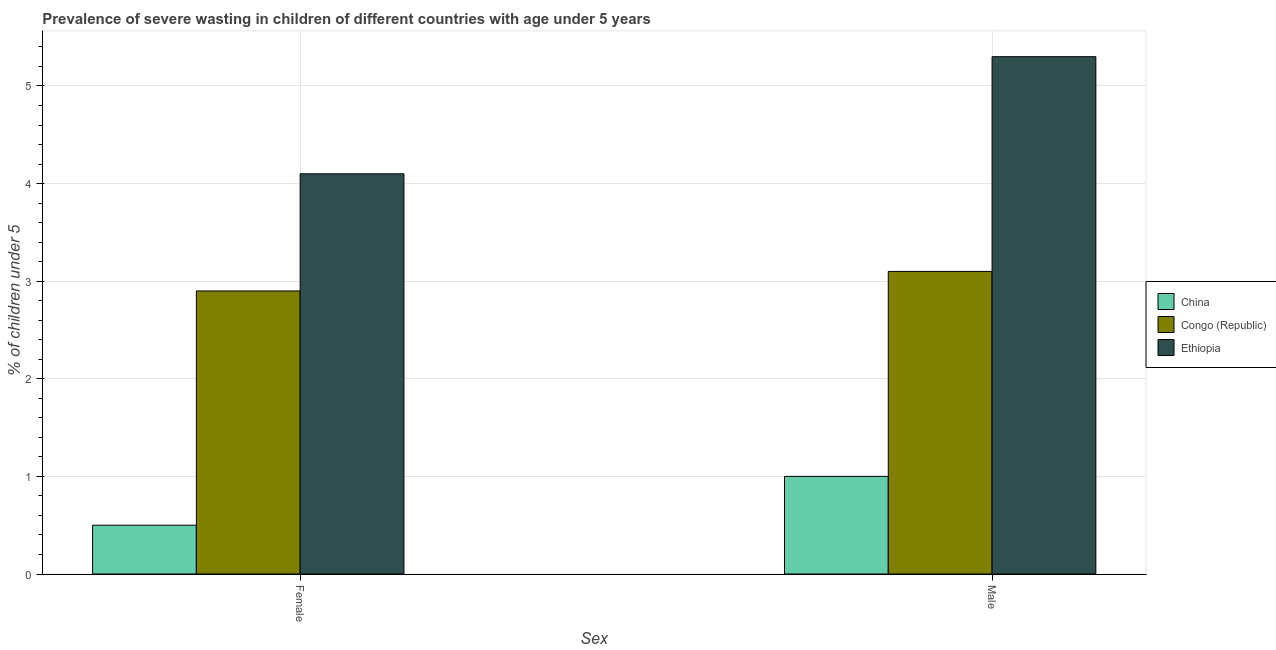How many different coloured bars are there?
Ensure brevity in your answer.  3. How many bars are there on the 2nd tick from the left?
Provide a succinct answer. 3. How many bars are there on the 1st tick from the right?
Keep it short and to the point. 3. What is the percentage of undernourished male children in Congo (Republic)?
Your response must be concise. 3.1. Across all countries, what is the maximum percentage of undernourished male children?
Make the answer very short. 5.3. Across all countries, what is the minimum percentage of undernourished female children?
Give a very brief answer. 0.5. In which country was the percentage of undernourished male children maximum?
Your answer should be compact. Ethiopia. What is the total percentage of undernourished male children in the graph?
Your answer should be very brief. 9.4. What is the difference between the percentage of undernourished male children in China and that in Congo (Republic)?
Keep it short and to the point. -2.1. What is the difference between the percentage of undernourished female children in Congo (Republic) and the percentage of undernourished male children in China?
Provide a succinct answer. 1.9. What is the average percentage of undernourished male children per country?
Your answer should be compact. 3.13. In how many countries, is the percentage of undernourished female children greater than 2 %?
Give a very brief answer. 2. What is the ratio of the percentage of undernourished female children in Congo (Republic) to that in China?
Give a very brief answer. 5.8. What does the 1st bar from the right in Male represents?
Make the answer very short. Ethiopia. What is the difference between two consecutive major ticks on the Y-axis?
Keep it short and to the point. 1. Are the values on the major ticks of Y-axis written in scientific E-notation?
Make the answer very short. No. Does the graph contain any zero values?
Offer a terse response. No. Where does the legend appear in the graph?
Give a very brief answer. Center right. How are the legend labels stacked?
Your response must be concise. Vertical. What is the title of the graph?
Keep it short and to the point. Prevalence of severe wasting in children of different countries with age under 5 years. What is the label or title of the X-axis?
Offer a very short reply. Sex. What is the label or title of the Y-axis?
Your answer should be very brief.  % of children under 5. What is the  % of children under 5 of Congo (Republic) in Female?
Keep it short and to the point. 2.9. What is the  % of children under 5 in Ethiopia in Female?
Your answer should be compact. 4.1. What is the  % of children under 5 of Congo (Republic) in Male?
Offer a terse response. 3.1. What is the  % of children under 5 of Ethiopia in Male?
Give a very brief answer. 5.3. Across all Sex, what is the maximum  % of children under 5 in China?
Keep it short and to the point. 1. Across all Sex, what is the maximum  % of children under 5 of Congo (Republic)?
Ensure brevity in your answer.  3.1. Across all Sex, what is the maximum  % of children under 5 of Ethiopia?
Offer a terse response. 5.3. Across all Sex, what is the minimum  % of children under 5 of China?
Provide a short and direct response. 0.5. Across all Sex, what is the minimum  % of children under 5 of Congo (Republic)?
Provide a short and direct response. 2.9. Across all Sex, what is the minimum  % of children under 5 of Ethiopia?
Your response must be concise. 4.1. What is the total  % of children under 5 in Congo (Republic) in the graph?
Keep it short and to the point. 6. What is the total  % of children under 5 of Ethiopia in the graph?
Your answer should be very brief. 9.4. What is the difference between the  % of children under 5 of China in Female and that in Male?
Give a very brief answer. -0.5. What is the difference between the  % of children under 5 of Congo (Republic) in Female and that in Male?
Offer a terse response. -0.2. What is the difference between the  % of children under 5 in China in Female and the  % of children under 5 in Congo (Republic) in Male?
Offer a terse response. -2.6. What is the average  % of children under 5 in Congo (Republic) per Sex?
Give a very brief answer. 3. What is the difference between the  % of children under 5 of Congo (Republic) and  % of children under 5 of Ethiopia in Female?
Your response must be concise. -1.2. What is the difference between the  % of children under 5 in China and  % of children under 5 in Congo (Republic) in Male?
Keep it short and to the point. -2.1. What is the difference between the  % of children under 5 of Congo (Republic) and  % of children under 5 of Ethiopia in Male?
Offer a very short reply. -2.2. What is the ratio of the  % of children under 5 of China in Female to that in Male?
Provide a short and direct response. 0.5. What is the ratio of the  % of children under 5 in Congo (Republic) in Female to that in Male?
Ensure brevity in your answer.  0.94. What is the ratio of the  % of children under 5 of Ethiopia in Female to that in Male?
Offer a very short reply. 0.77. What is the difference between the highest and the second highest  % of children under 5 in China?
Keep it short and to the point. 0.5. What is the difference between the highest and the lowest  % of children under 5 in China?
Provide a short and direct response. 0.5. 